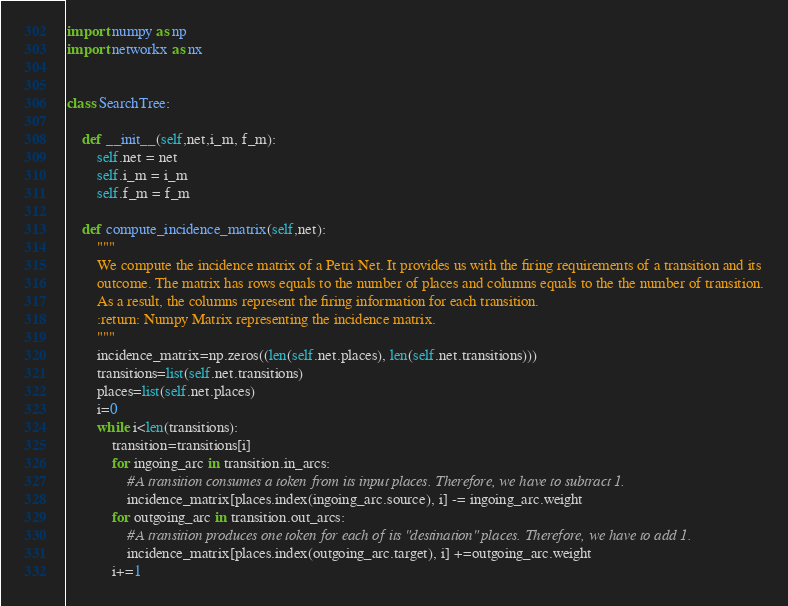<code> <loc_0><loc_0><loc_500><loc_500><_Python_>import numpy as np
import networkx as nx


class SearchTree:

    def __init__(self,net,i_m, f_m):
        self.net = net
        self.i_m = i_m
        self.f_m = f_m

    def compute_incidence_matrix(self,net):
        """
        We compute the incidence matrix of a Petri Net. It provides us with the firing requirements of a transition and its
        outcome. The matrix has rows equals to the number of places and columns equals to the the number of transition.
        As a result, the columns represent the firing information for each transition.
        :return: Numpy Matrix representing the incidence matrix.
        """
        incidence_matrix=np.zeros((len(self.net.places), len(self.net.transitions)))
        transitions=list(self.net.transitions)
        places=list(self.net.places)
        i=0
        while i<len(transitions):
            transition=transitions[i]
            for ingoing_arc in transition.in_arcs:
                #A transition consumes a token from its input places. Therefore, we have to subtract 1.
                incidence_matrix[places.index(ingoing_arc.source), i] -= ingoing_arc.weight
            for outgoing_arc in transition.out_arcs:
                #A transition produces one token for each of its "destination" places. Therefore, we have to add 1.
                incidence_matrix[places.index(outgoing_arc.target), i] +=outgoing_arc.weight
            i+=1</code> 